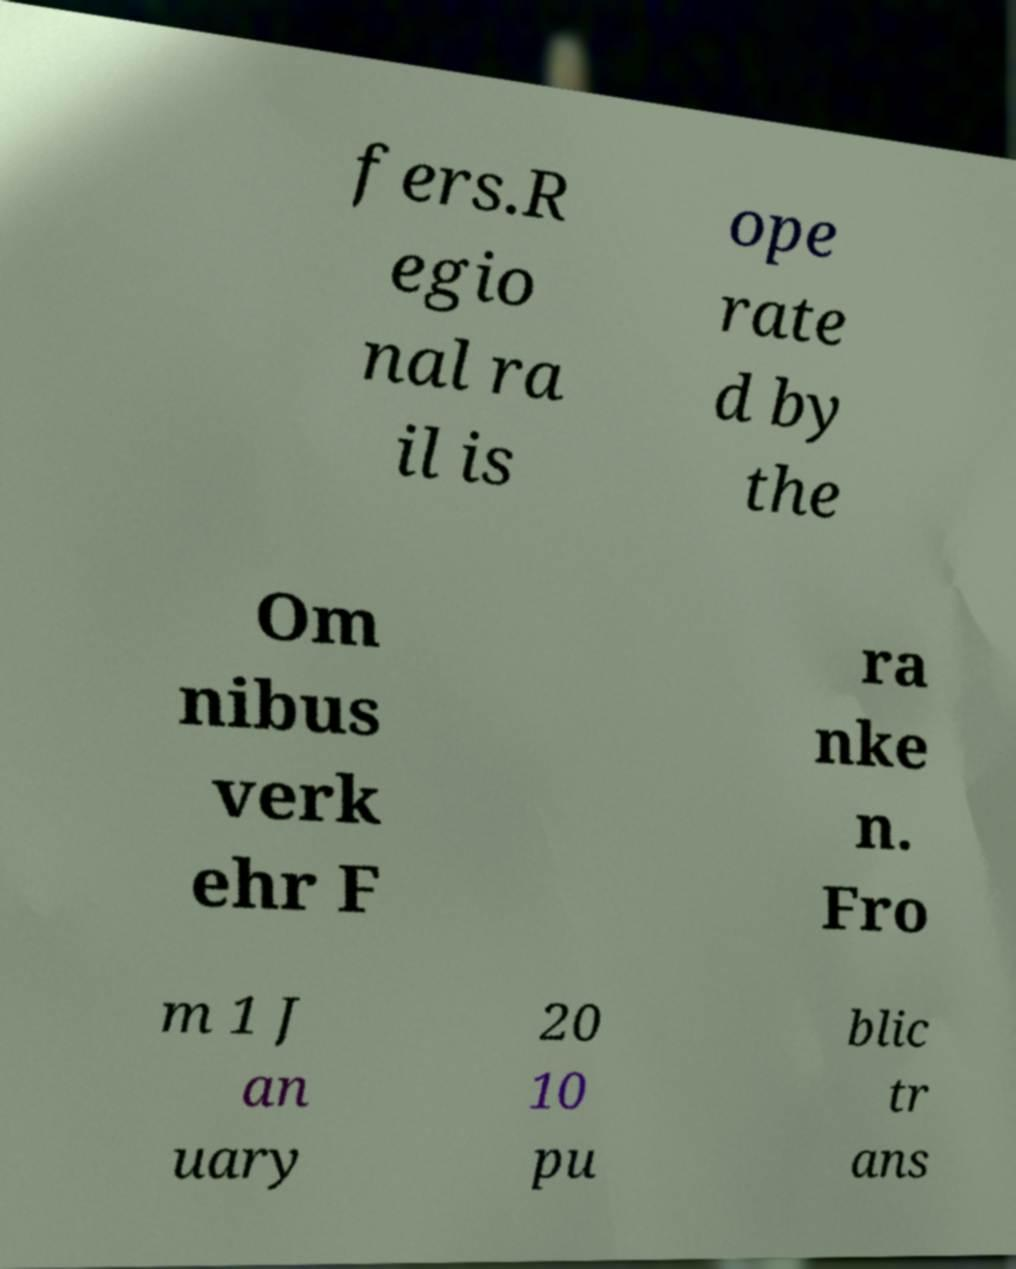Can you accurately transcribe the text from the provided image for me? fers.R egio nal ra il is ope rate d by the Om nibus verk ehr F ra nke n. Fro m 1 J an uary 20 10 pu blic tr ans 